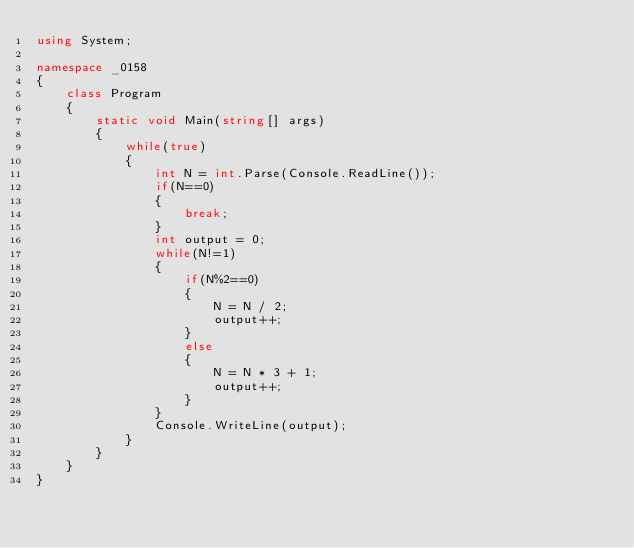<code> <loc_0><loc_0><loc_500><loc_500><_C#_>using System;

namespace _0158
{
    class Program
    {
        static void Main(string[] args)
        {
            while(true)
            {
                int N = int.Parse(Console.ReadLine());
                if(N==0)
                {
                    break;
                }
                int output = 0;
                while(N!=1)
                {
                    if(N%2==0)
                    {
                        N = N / 2;
                        output++;
                    }
                    else
                    {
                        N = N * 3 + 1;
                        output++;
                    }
                }
                Console.WriteLine(output);
            }
        }
    }
}</code> 